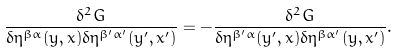<formula> <loc_0><loc_0><loc_500><loc_500>\frac { \delta ^ { 2 } G } { \delta \eta ^ { \beta \alpha } ( y , x ) \delta \eta ^ { \beta ^ { \prime } \alpha ^ { \prime } } ( y ^ { \prime } , x ^ { \prime } ) } = - \frac { \delta ^ { 2 } G } { \delta \eta ^ { \beta ^ { \prime } \alpha } ( y ^ { \prime } , x ) \delta \eta ^ { \beta \alpha ^ { \prime } } ( y , x ^ { \prime } ) } .</formula> 